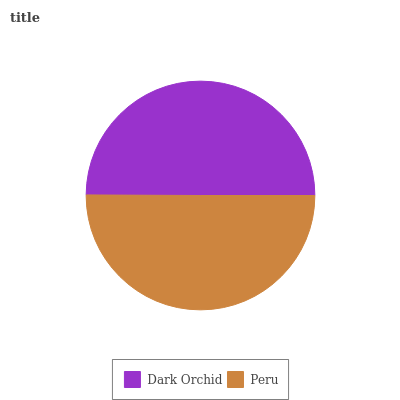Is Dark Orchid the minimum?
Answer yes or no. Yes. Is Peru the maximum?
Answer yes or no. Yes. Is Peru the minimum?
Answer yes or no. No. Is Peru greater than Dark Orchid?
Answer yes or no. Yes. Is Dark Orchid less than Peru?
Answer yes or no. Yes. Is Dark Orchid greater than Peru?
Answer yes or no. No. Is Peru less than Dark Orchid?
Answer yes or no. No. Is Peru the high median?
Answer yes or no. Yes. Is Dark Orchid the low median?
Answer yes or no. Yes. Is Dark Orchid the high median?
Answer yes or no. No. Is Peru the low median?
Answer yes or no. No. 